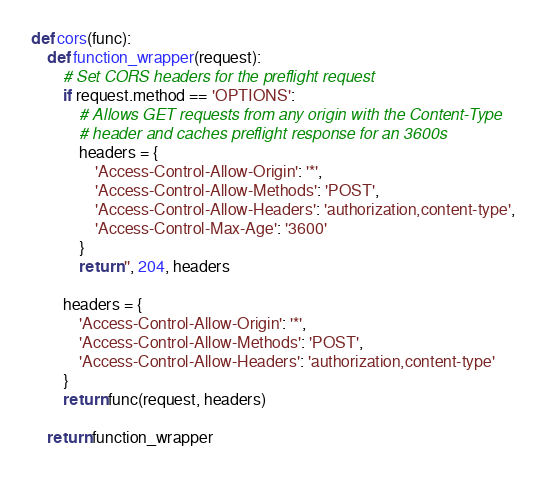Convert code to text. <code><loc_0><loc_0><loc_500><loc_500><_Python_>def cors(func):
    def function_wrapper(request):
        # Set CORS headers for the preflight request
        if request.method == 'OPTIONS':
            # Allows GET requests from any origin with the Content-Type
            # header and caches preflight response for an 3600s
            headers = {
                'Access-Control-Allow-Origin': '*',
                'Access-Control-Allow-Methods': 'POST',
                'Access-Control-Allow-Headers': 'authorization,content-type',
                'Access-Control-Max-Age': '3600'
            }
            return '', 204, headers

        headers = {
            'Access-Control-Allow-Origin': '*',
            'Access-Control-Allow-Methods': 'POST',
            'Access-Control-Allow-Headers': 'authorization,content-type'
        }
        return func(request, headers)

    return function_wrapper
</code> 